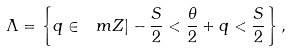<formula> <loc_0><loc_0><loc_500><loc_500>\Lambda = \left \{ q \in \ m Z | - \frac { S } { 2 } < \frac { \theta } { 2 } + q < \frac { S } { 2 } \right \} ,</formula> 